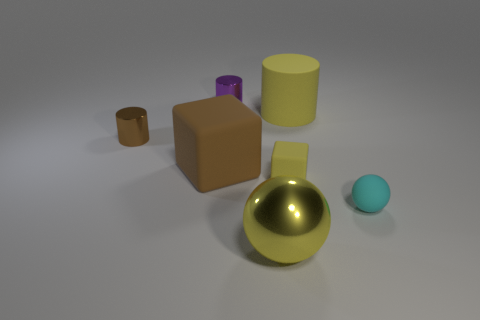Subtract all tiny purple shiny cylinders. How many cylinders are left? 2 Subtract all cyan balls. How many balls are left? 1 Subtract all cylinders. How many objects are left? 4 Subtract 2 blocks. How many blocks are left? 0 Add 2 large gray rubber cubes. How many objects exist? 9 Subtract 0 gray cubes. How many objects are left? 7 Subtract all yellow cylinders. Subtract all blue balls. How many cylinders are left? 2 Subtract all yellow cylinders. How many brown blocks are left? 1 Subtract all large yellow rubber cylinders. Subtract all small matte spheres. How many objects are left? 5 Add 4 balls. How many balls are left? 6 